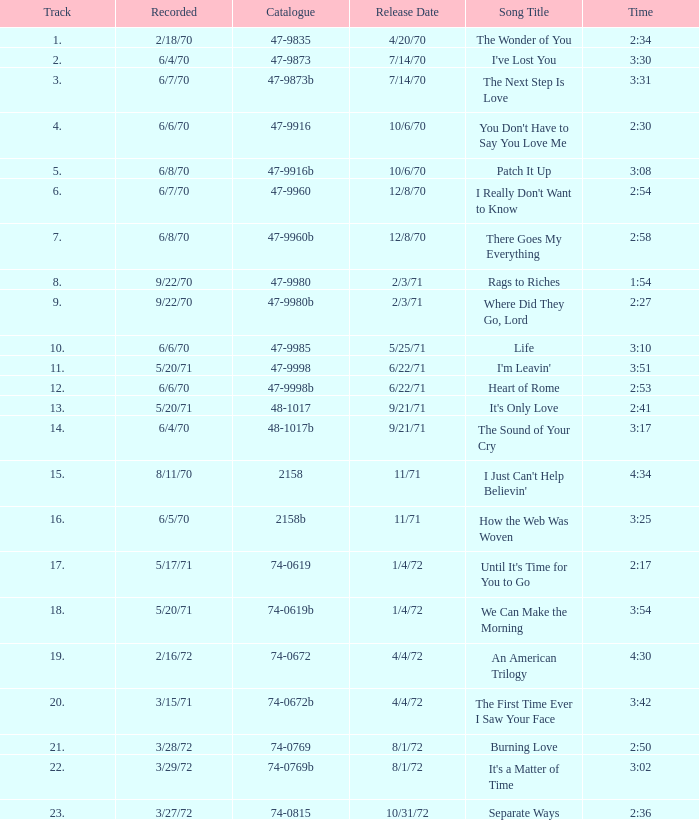What is the catalog number of the 3:17 song released on september 21, 1971? 48-1017b. 